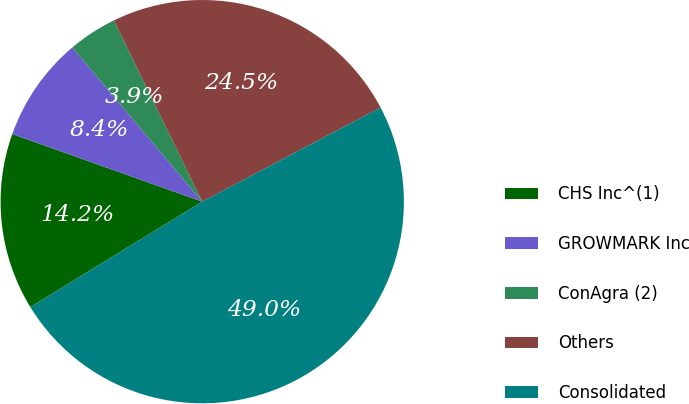Convert chart to OTSL. <chart><loc_0><loc_0><loc_500><loc_500><pie_chart><fcel>CHS Inc^(1)<fcel>GROWMARK Inc<fcel>ConAgra (2)<fcel>Others<fcel>Consolidated<nl><fcel>14.2%<fcel>8.42%<fcel>3.92%<fcel>24.49%<fcel>48.97%<nl></chart> 